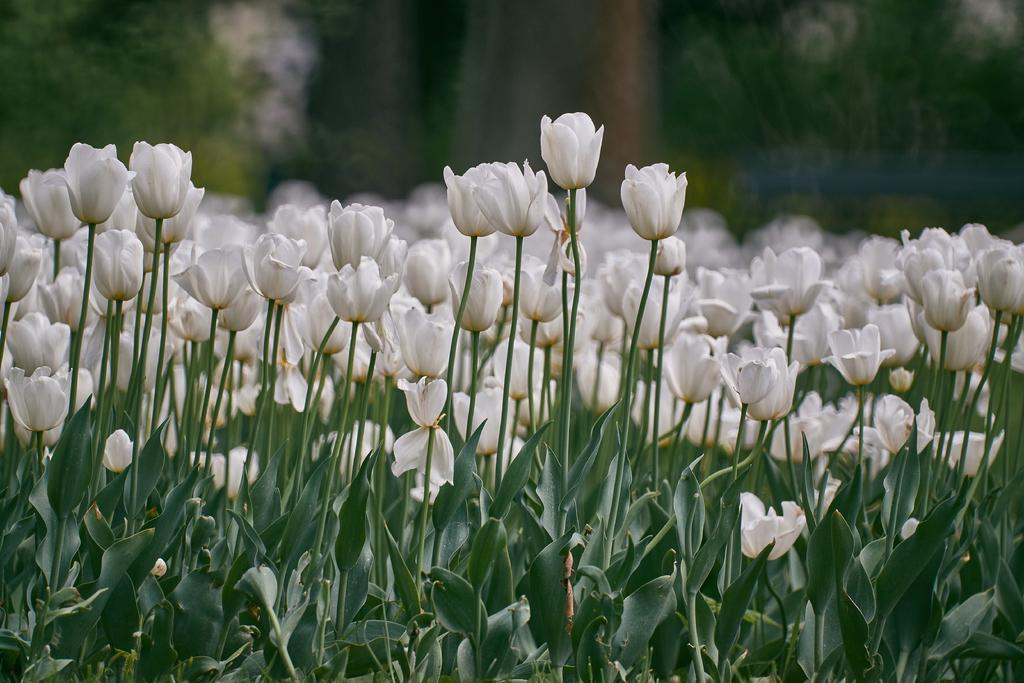What type of living organisms can be seen in the image? There are flowers and plants in the image. Can you describe the background of the image? The background of the image is blurred, but it contains greenery. What type of fiction is being developed in the image? There is no reference to fiction or development in the image; it features flowers and plants with a blurred background. 